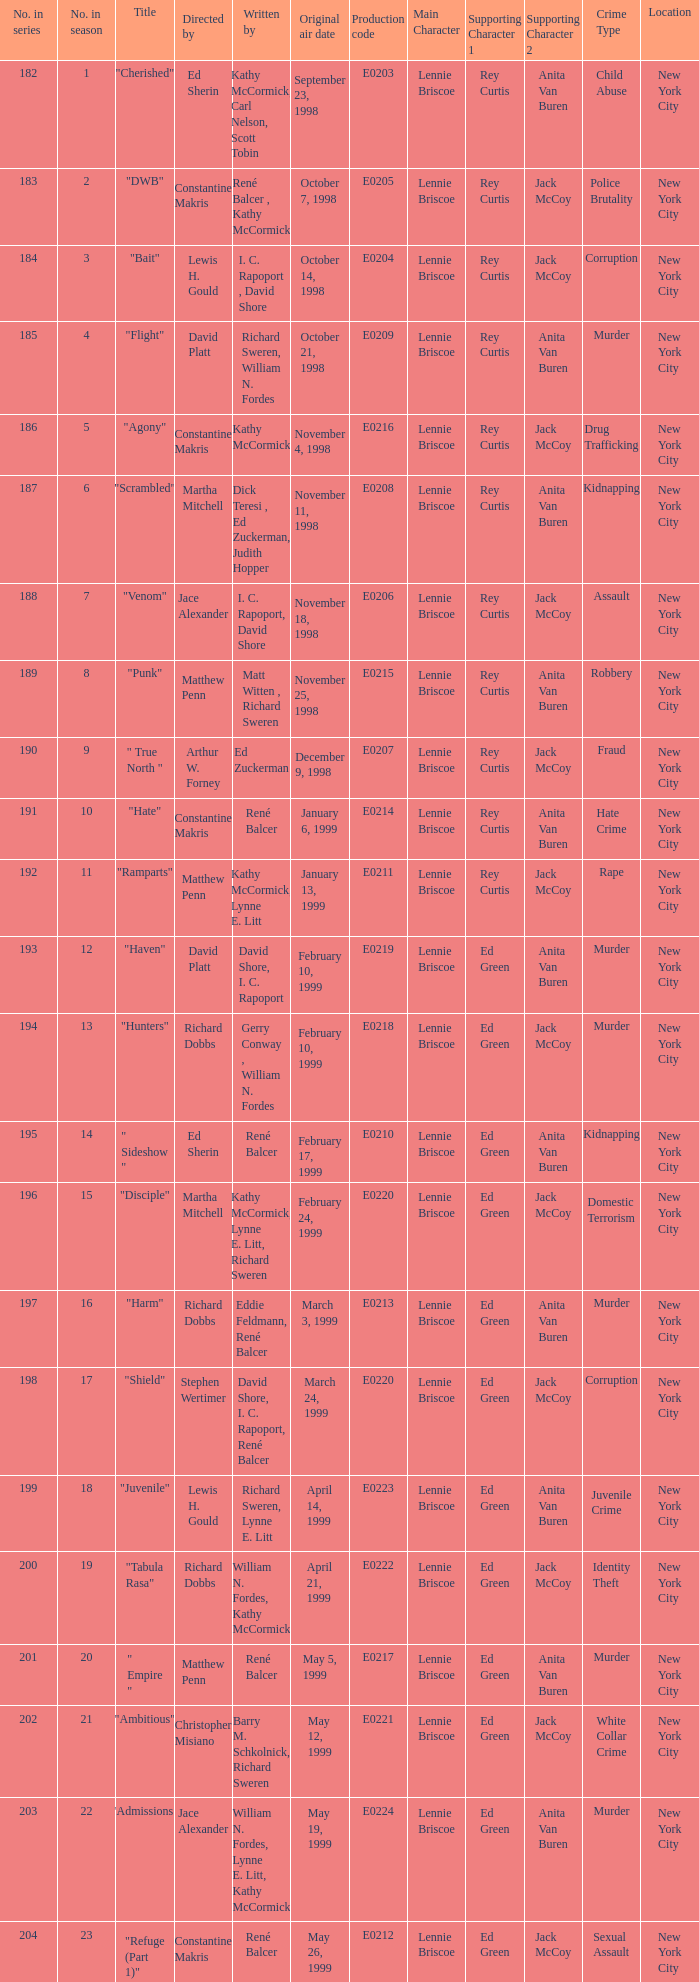The episode with the production code E0208 is directed by who? Martha Mitchell. 